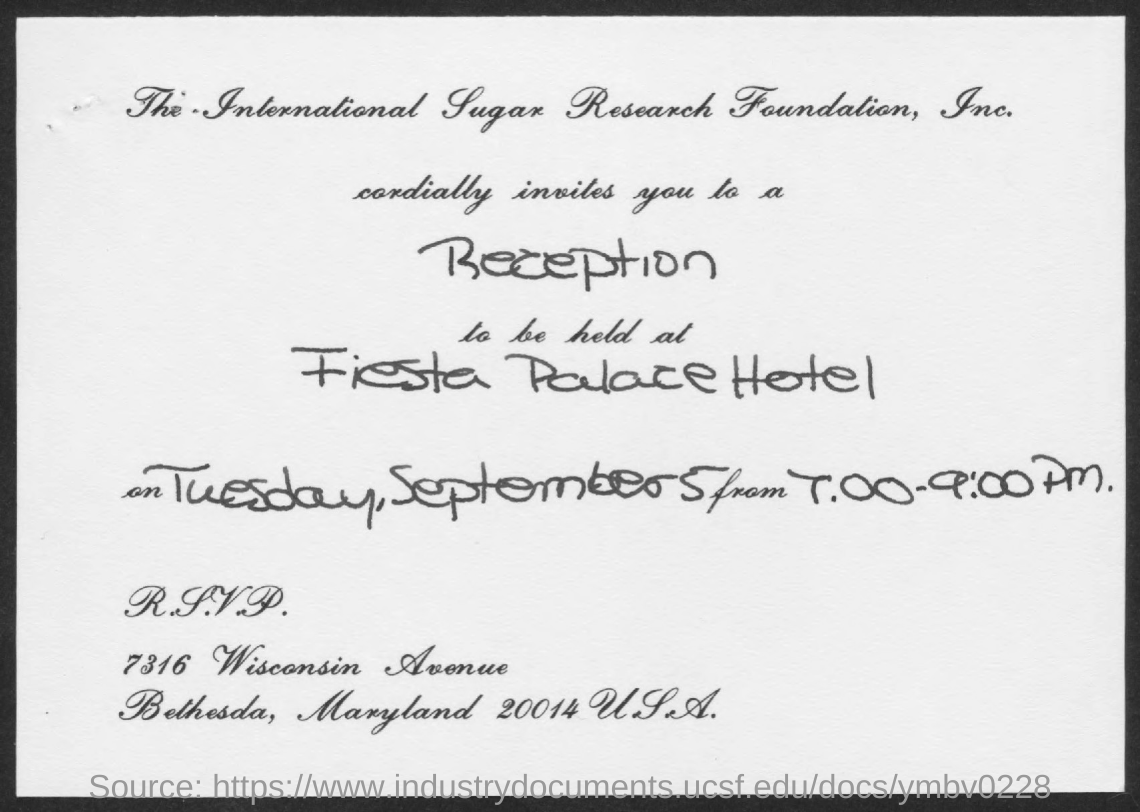What is the date mentioned in the document?
Offer a very short reply. Tuesday, september5. Reception is held at which hotel?
Your response must be concise. Fiesta palace hotel. 